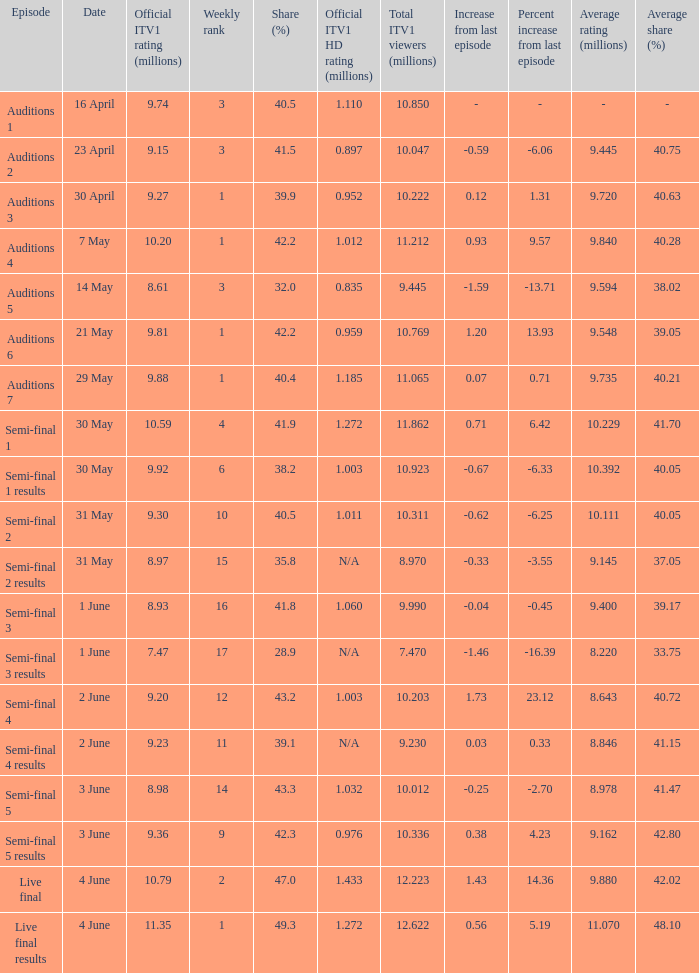What was the share (%) for the Semi-Final 2 episode?  40.5. 